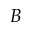Convert formula to latex. <formula><loc_0><loc_0><loc_500><loc_500>B</formula> 